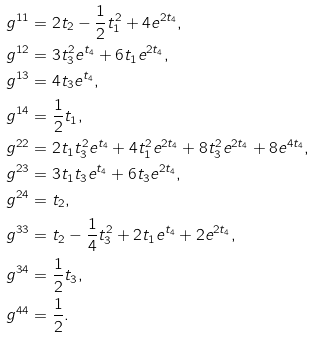<formula> <loc_0><loc_0><loc_500><loc_500>& g ^ { 1 1 } = 2 t _ { 2 } - \frac { 1 } { 2 } t _ { 1 } ^ { 2 } + 4 e ^ { 2 t _ { 4 } } , \\ & g ^ { 1 2 } = 3 t _ { 3 } ^ { 2 } e ^ { t _ { 4 } } + 6 t _ { 1 } e ^ { 2 t _ { 4 } } , \\ & g ^ { 1 3 } = 4 t _ { 3 } e ^ { t _ { 4 } } , \\ & g ^ { 1 4 } = \frac { 1 } { 2 } t _ { 1 } , \\ & g ^ { 2 2 } = 2 t _ { 1 } t _ { 3 } ^ { 2 } e ^ { t _ { 4 } } + 4 t _ { 1 } ^ { 2 } e ^ { 2 t _ { 4 } } + 8 t _ { 3 } ^ { 2 } e ^ { 2 t _ { 4 } } + 8 e ^ { 4 t _ { 4 } } , \\ & g ^ { 2 3 } = 3 t _ { 1 } t _ { 3 } e ^ { t _ { 4 } } + 6 t _ { 3 } e ^ { 2 t _ { 4 } } , \\ & g ^ { 2 4 } = t _ { 2 } , \\ & g ^ { 3 3 } = t _ { 2 } - \frac { 1 } { 4 } t _ { 3 } ^ { 2 } + 2 t _ { 1 } e ^ { t _ { 4 } } + 2 e ^ { 2 t _ { 4 } } , \\ & g ^ { 3 4 } = \frac { 1 } { 2 } t _ { 3 } , \\ & g ^ { 4 4 } = \frac { 1 } { 2 } .</formula> 